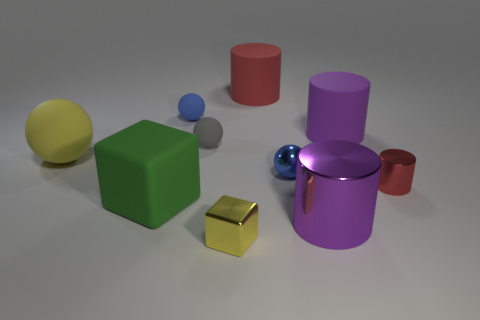Is the shape of the green rubber object the same as the tiny red thing?
Make the answer very short. No. What is the material of the big thing that is right of the yellow rubber ball and to the left of the small gray rubber thing?
Your response must be concise. Rubber. What number of big green rubber things are the same shape as the purple metal object?
Your answer should be compact. 0. There is a gray matte sphere in front of the blue matte ball that is behind the sphere that is to the right of the small yellow metallic thing; what size is it?
Give a very brief answer. Small. Are there more gray balls behind the tiny gray sphere than large gray cubes?
Give a very brief answer. No. Are there any large gray things?
Make the answer very short. No. What number of purple objects have the same size as the yellow matte object?
Offer a terse response. 2. Are there more tiny yellow shiny objects that are to the right of the red rubber object than matte cylinders that are on the left side of the small yellow metal object?
Your answer should be very brief. No. What is the material of the yellow thing that is the same size as the purple matte object?
Keep it short and to the point. Rubber. There is a big green rubber object; what shape is it?
Provide a short and direct response. Cube. 